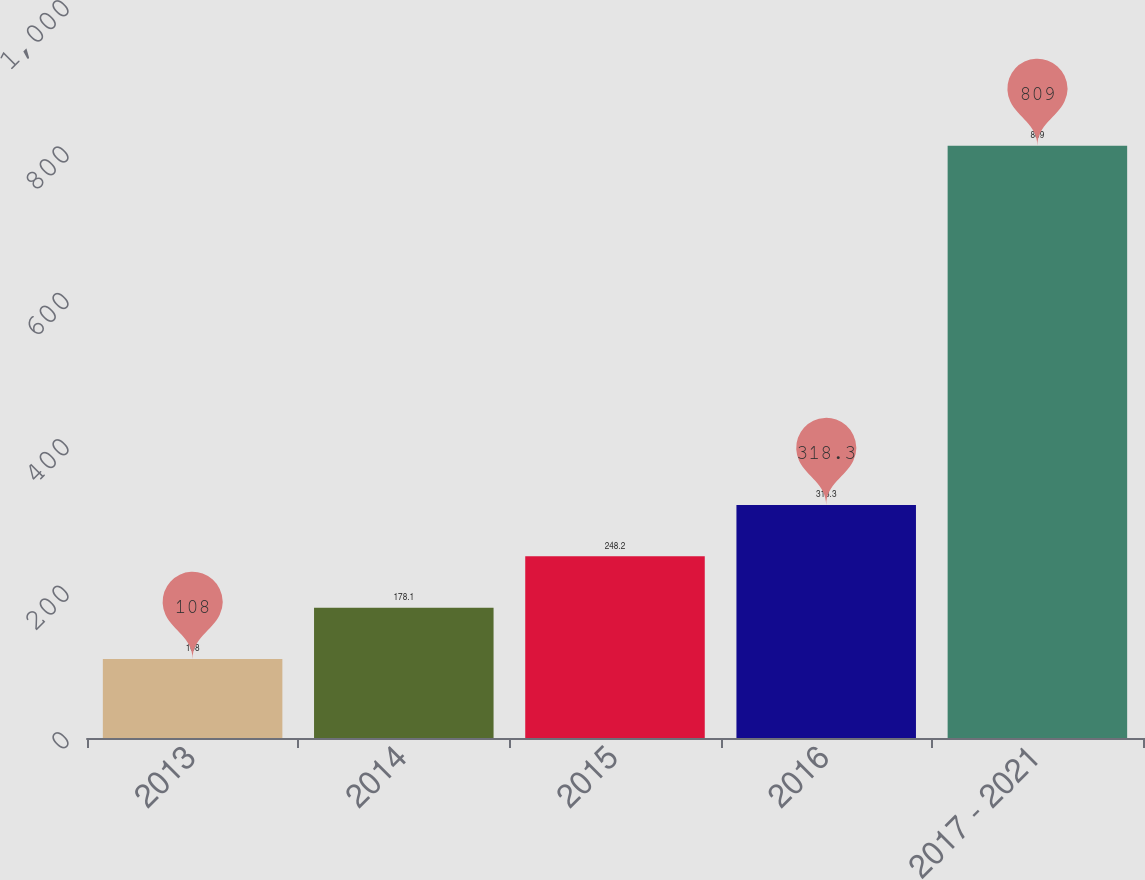Convert chart to OTSL. <chart><loc_0><loc_0><loc_500><loc_500><bar_chart><fcel>2013<fcel>2014<fcel>2015<fcel>2016<fcel>2017 - 2021<nl><fcel>108<fcel>178.1<fcel>248.2<fcel>318.3<fcel>809<nl></chart> 